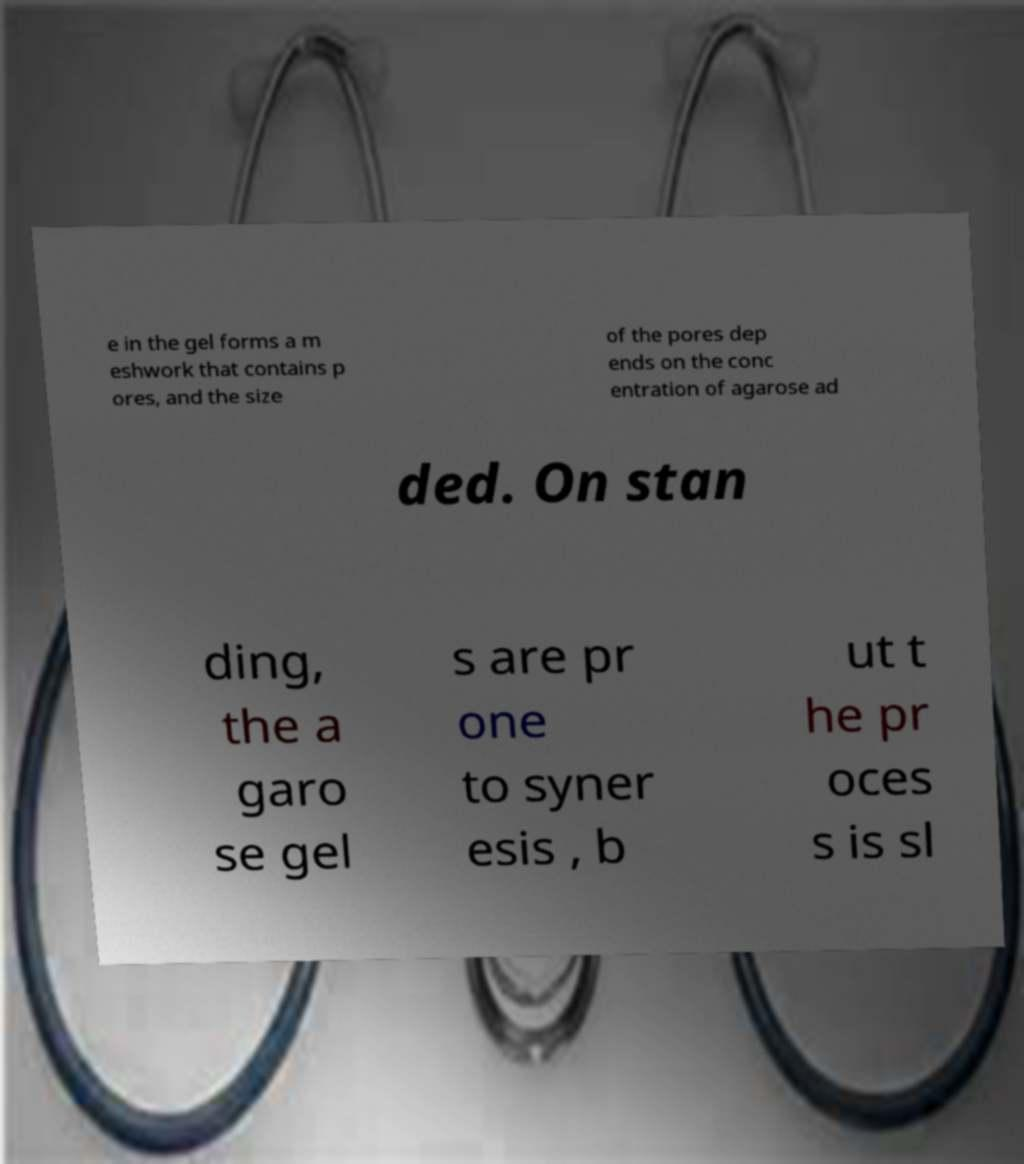Can you read and provide the text displayed in the image?This photo seems to have some interesting text. Can you extract and type it out for me? e in the gel forms a m eshwork that contains p ores, and the size of the pores dep ends on the conc entration of agarose ad ded. On stan ding, the a garo se gel s are pr one to syner esis , b ut t he pr oces s is sl 